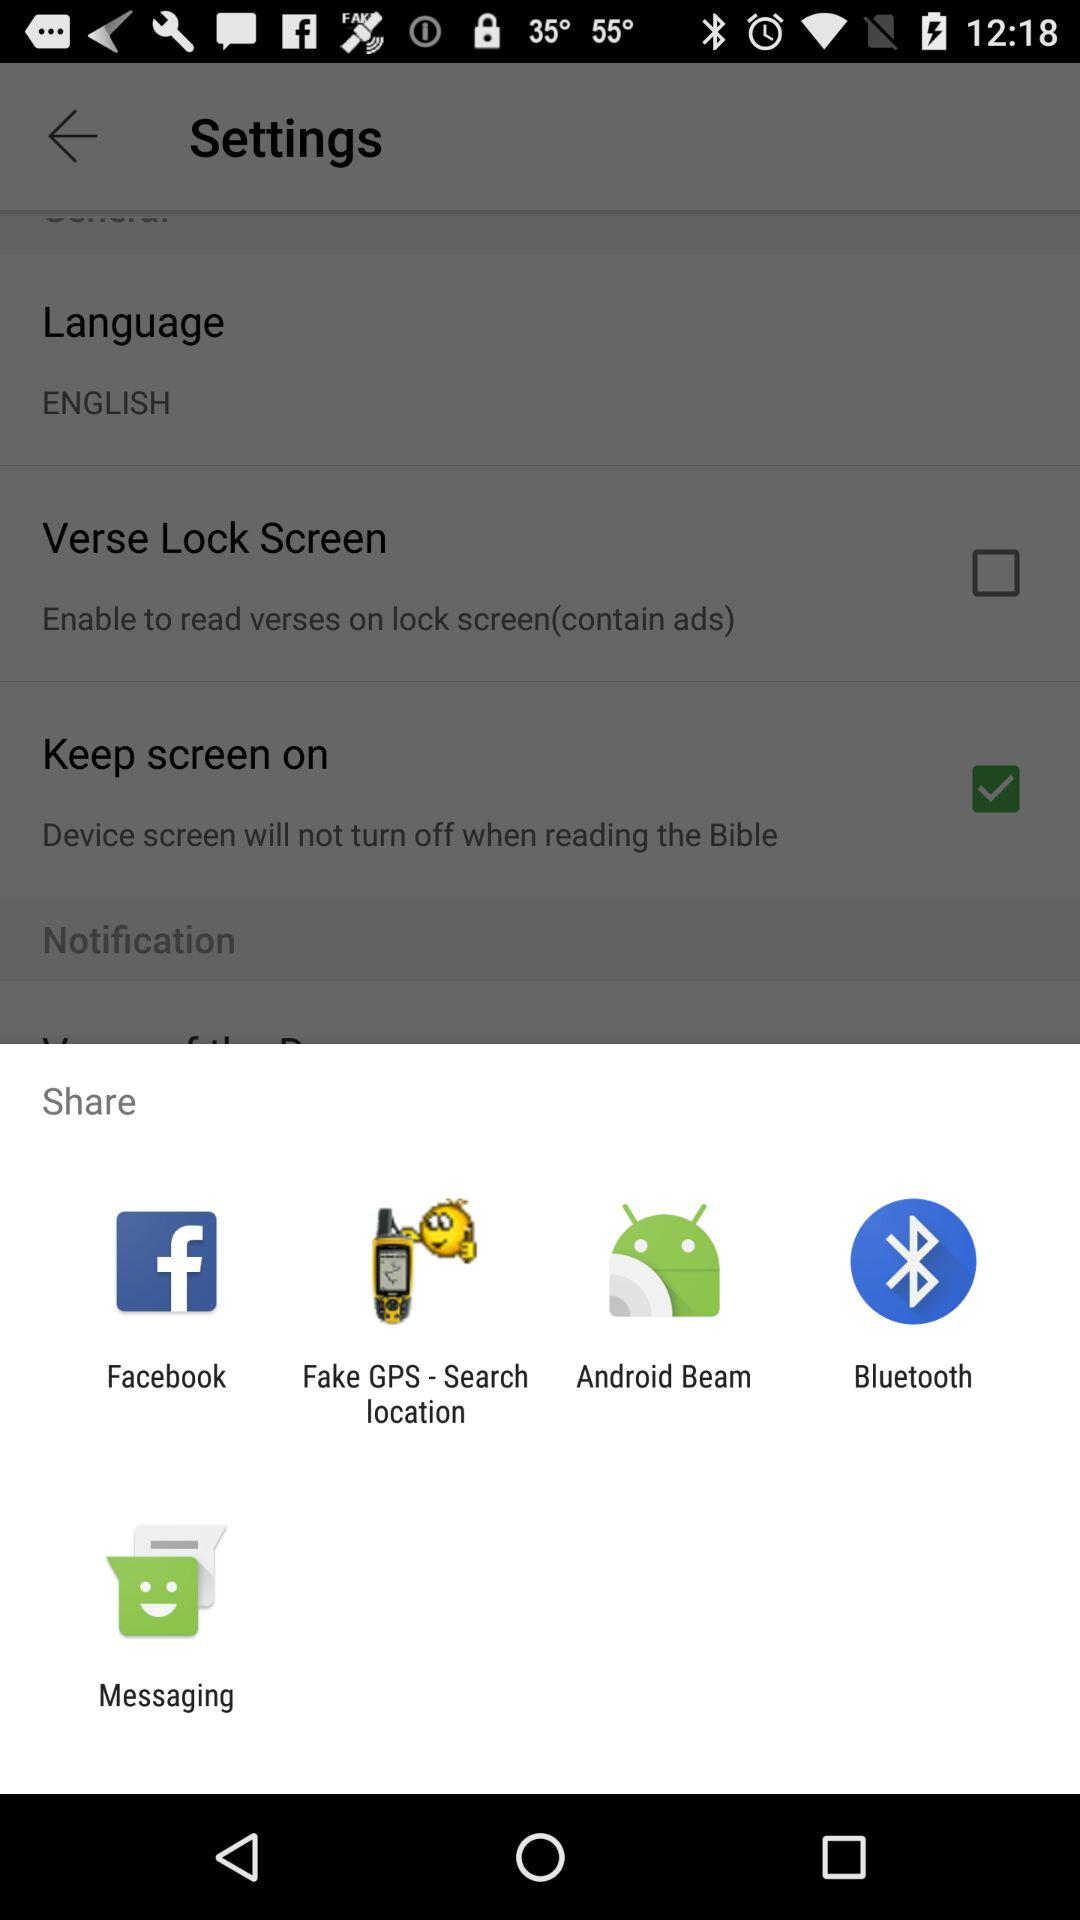What is the version of this application?
When the provided information is insufficient, respond with <no answer>. <no answer> 